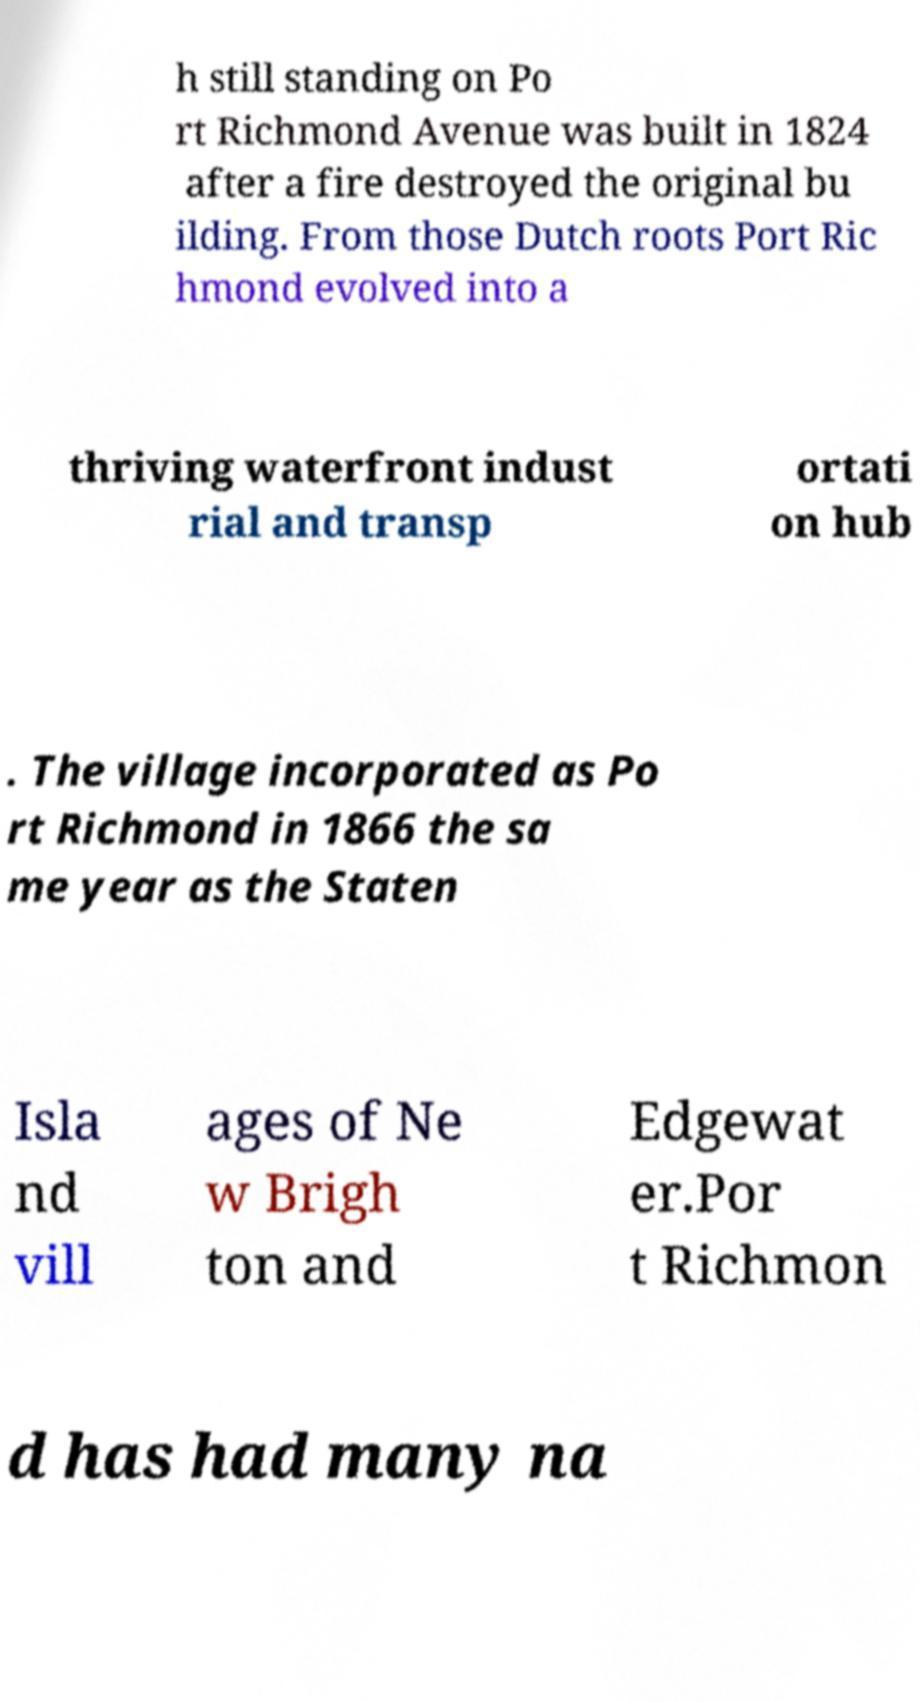I need the written content from this picture converted into text. Can you do that? h still standing on Po rt Richmond Avenue was built in 1824 after a fire destroyed the original bu ilding. From those Dutch roots Port Ric hmond evolved into a thriving waterfront indust rial and transp ortati on hub . The village incorporated as Po rt Richmond in 1866 the sa me year as the Staten Isla nd vill ages of Ne w Brigh ton and Edgewat er.Por t Richmon d has had many na 